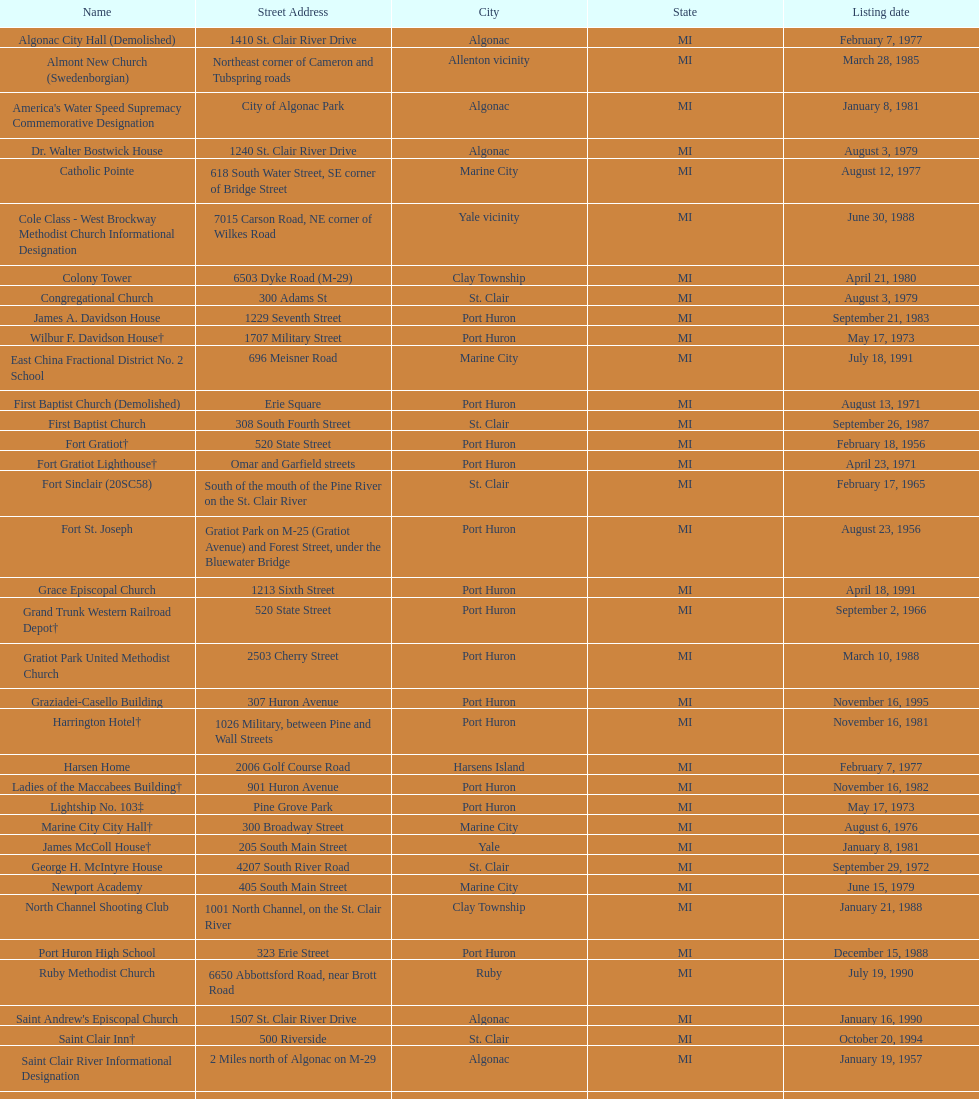What is the number of properties on the list that have been demolished? 2. 